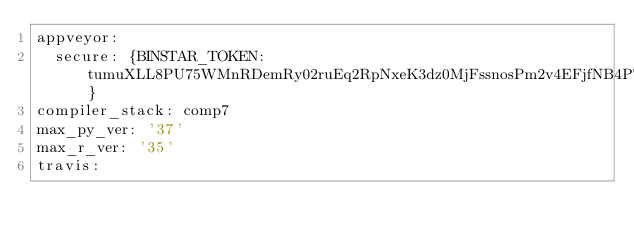Convert code to text. <code><loc_0><loc_0><loc_500><loc_500><_YAML_>appveyor:
  secure: {BINSTAR_TOKEN: tumuXLL8PU75WMnRDemRy02ruEq2RpNxeK3dz0MjFssnosPm2v4EFjfNB4PTotA1}
compiler_stack: comp7
max_py_ver: '37'
max_r_ver: '35'
travis:</code> 